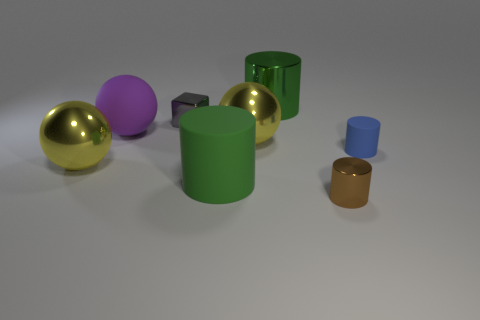Is the color of the big metallic cylinder the same as the large rubber cylinder?
Your answer should be compact. Yes. There is a shiny cylinder that is behind the tiny metal thing that is in front of the large yellow shiny ball on the left side of the small metal block; what size is it?
Offer a very short reply. Large. Is the number of small blue things in front of the purple rubber object greater than the number of small green shiny cylinders?
Your response must be concise. Yes. Does the green rubber object have the same shape as the large green thing that is behind the cube?
Offer a very short reply. Yes. The other green thing that is the same shape as the big green metallic thing is what size?
Your answer should be compact. Large. Is the number of big purple spheres greater than the number of tiny cyan objects?
Make the answer very short. Yes. Do the blue rubber thing and the tiny gray shiny thing have the same shape?
Provide a short and direct response. No. What is the material of the object that is to the right of the small shiny object that is in front of the purple thing?
Provide a succinct answer. Rubber. There is a object that is the same color as the large rubber cylinder; what material is it?
Your answer should be compact. Metal. Does the blue rubber thing have the same size as the gray object?
Provide a short and direct response. Yes. 